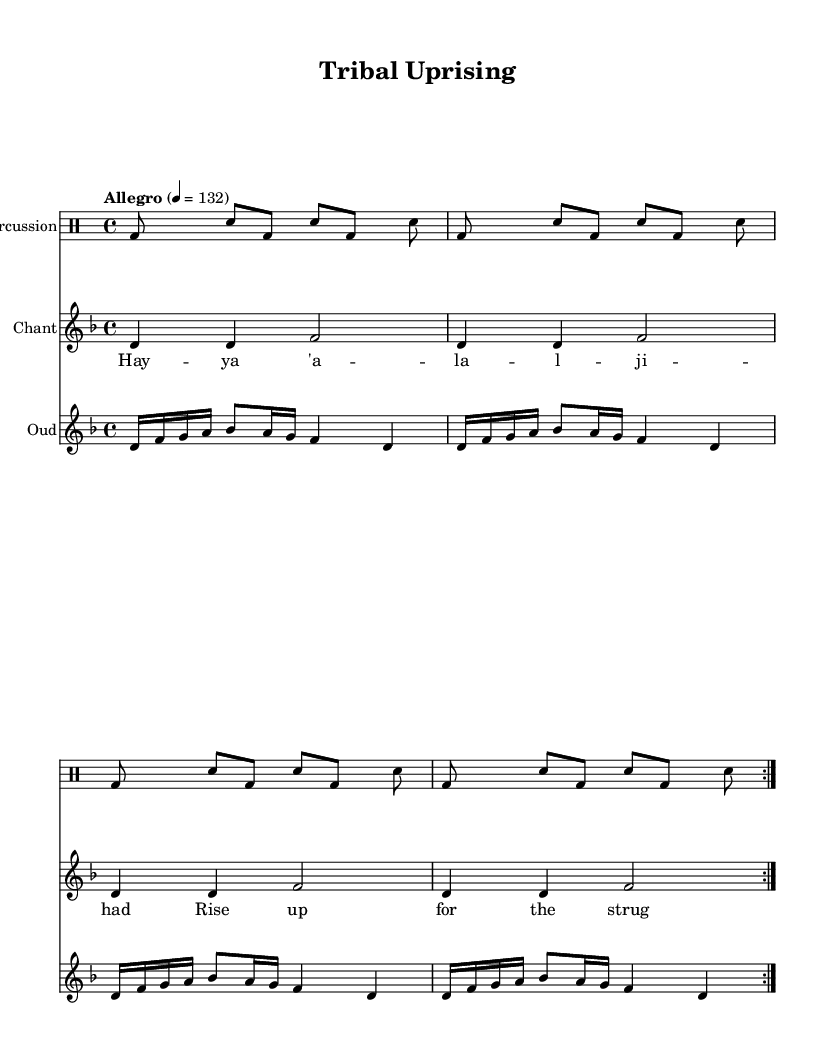What is the key signature of this music? The key signature is D minor, indicated by one flat (B♭). The notice of the key is typically found at the beginning of the staff where the clef is indicated.
Answer: D minor What is the time signature of this music? The time signature is 4/4, which means there are four beats in each measure and the quarter note gets one beat. This is shown at the start of the staff before any notes are placed.
Answer: 4/4 What is the tempo marking for this piece? The tempo marking is "Allegro," which is generally fast and lively. This marking often appears above the time signature in the music sheet, denoting the speed at which the piece should be played.
Answer: Allegro How many measures are there in the percussion part? There are eight measures in the percussion part, as indicated by the repetition and structure of the drummode section which consists of two main phrases, each repeated.
Answer: Eight What rhythmic instruments are used in this score? The score includes percussion, specifically indicated by the drum staff, and an oud which is a stringed instrument. The presence of these instruments can be identified by the labeled staff and the notated rhythmic patterns.
Answer: Percussion and oud What do the lyrics above the chant section ask for? The lyrics "Hayya 'ala al-jihad" translate to "Rise up for the struggle," which indicates a motivational and defiant message related to tribal uprisings. The lyrics are displayed in a lyric mode aligned with the corresponding notes in the chant staff.
Answer: Rise up for the struggle How many times is the chant repeated? The chant is repeated twice, as denoted by the volta markings in the chant section of the score. The repeat symbols indicate that this section should be played two times.
Answer: Twice 